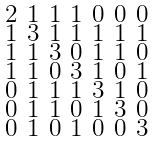Convert formula to latex. <formula><loc_0><loc_0><loc_500><loc_500>\begin{smallmatrix} 2 & 1 & 1 & 1 & 0 & 0 & 0 \\ 1 & 3 & 1 & 1 & 1 & 1 & 1 \\ 1 & 1 & 3 & 0 & 1 & 1 & 0 \\ 1 & 1 & 0 & 3 & 1 & 0 & 1 \\ 0 & 1 & 1 & 1 & 3 & 1 & 0 \\ 0 & 1 & 1 & 0 & 1 & 3 & 0 \\ 0 & 1 & 0 & 1 & 0 & 0 & 3 \end{smallmatrix}</formula> 